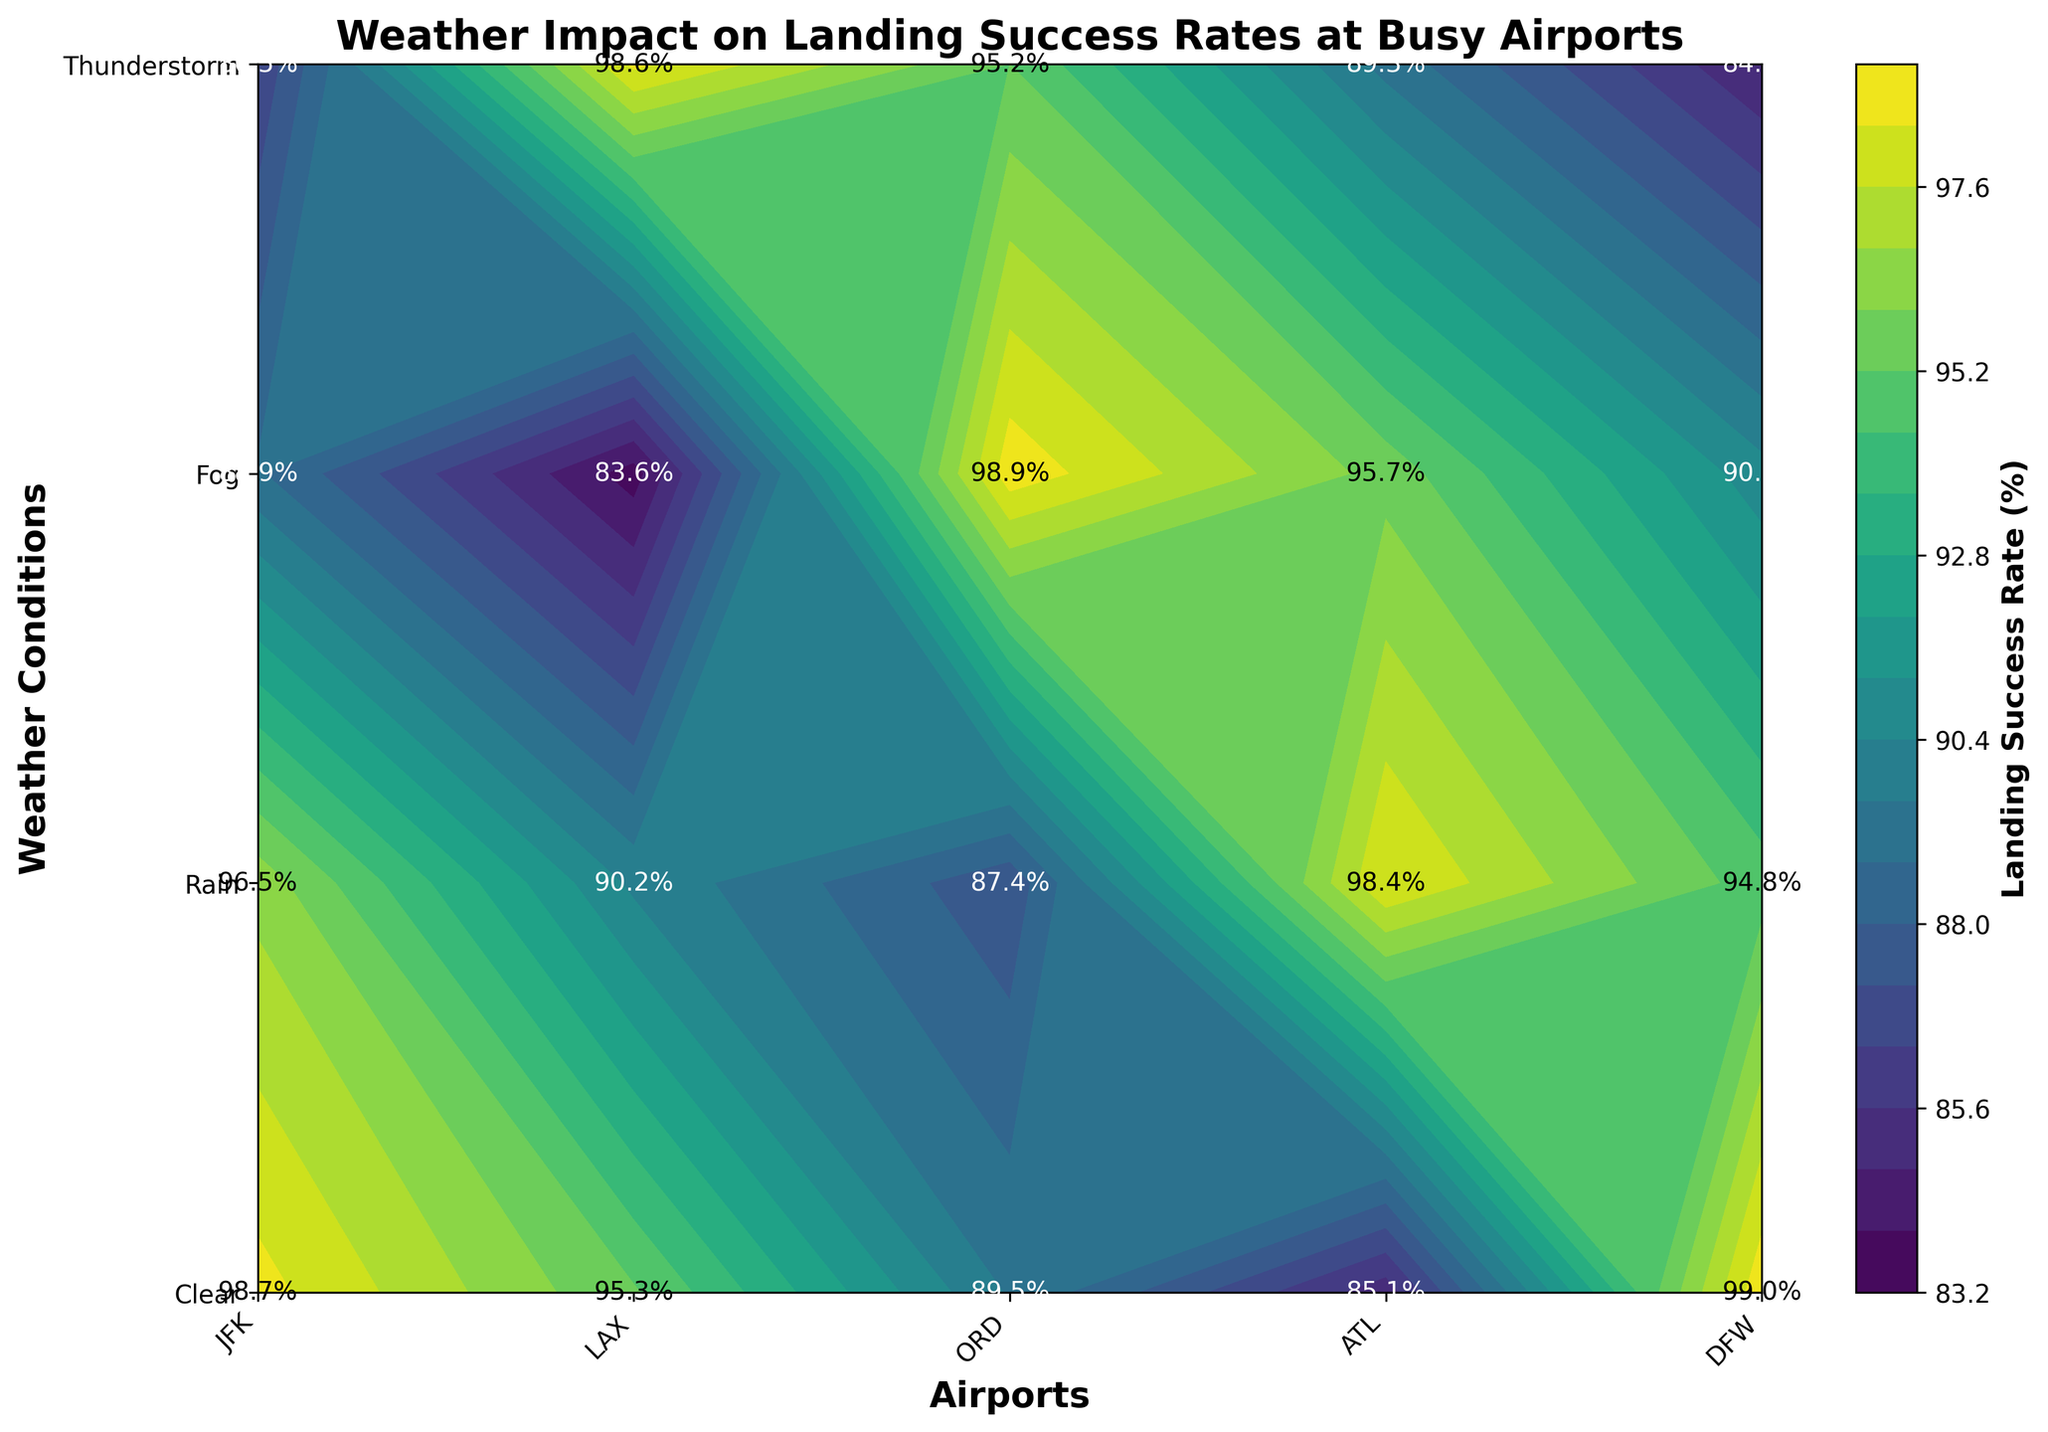What is the title of the figure? The title is located at the top of the figure and describes what the figure is about.
Answer: Weather Impact on Landing Success Rates at Busy Airports Which airport has the highest landing success rate in clear weather? By looking at the clear weather row and comparing the values for each airport, we see that LAX has the highest value at 99.0%.
Answer: LAX What is the landing success rate at ATL during a thunderstorm? Locate the cell where ATL and Thunderstorm intersect, and read the value in that cell, which is labeled as a percentage.
Answer: 86.5% What is the lowest landing success rate recorded in the figure? Scan through all the values in the contour plot to find the minimum value, which is at ORD during a thunderstorm.
Answer: 83.6% How does the landing success rate at JFK compare between clear weather and foggy weather? Compare the values of JFK in clear (98.7%) and foggy (89.5%) weather by calculating the difference: 98.7% - 89.5% = 9.2%.
Answer: Clear weather has 9.2% higher success rate than foggy weather Is the landing success rate during rain generally higher at ATL or ORD? Compare the success rates for rain at ATL (95.7%) and ORD (94.8%) by directly reading the values from the plot and noting the higher value.
Answer: ATL What is the average landing success rate during foggy weather across all airports? Sum the rates during fog (JFK: 89.5%, LAX: 90.2%, ORD: 88.9%, ATL: 90.7%, DFW: 89.3%) and divide by the number of airports: (89.5 + 90.2 + 88.9 + 90.7 + 89.3)/5 = 89.72%.
Answer: 89.72% Which weather condition shows the most significant impact on landing success rates across all examined airports? Analyze the largest overall decrease from the clear weather rates by comparing the averages of each weather condition. Thunderstorm generally shows the most apparent drops.
Answer: Thunderstorm How does the landing success rate in foggy weather at ORD compare to DFW? Compare the values for fog weather at ORD (88.9%) and DFW (89.3%) by subtracting ORD's value from DFW's: 89.3% - 88.9% = 0.4%.
Answer: DFW is 0.4% higher 